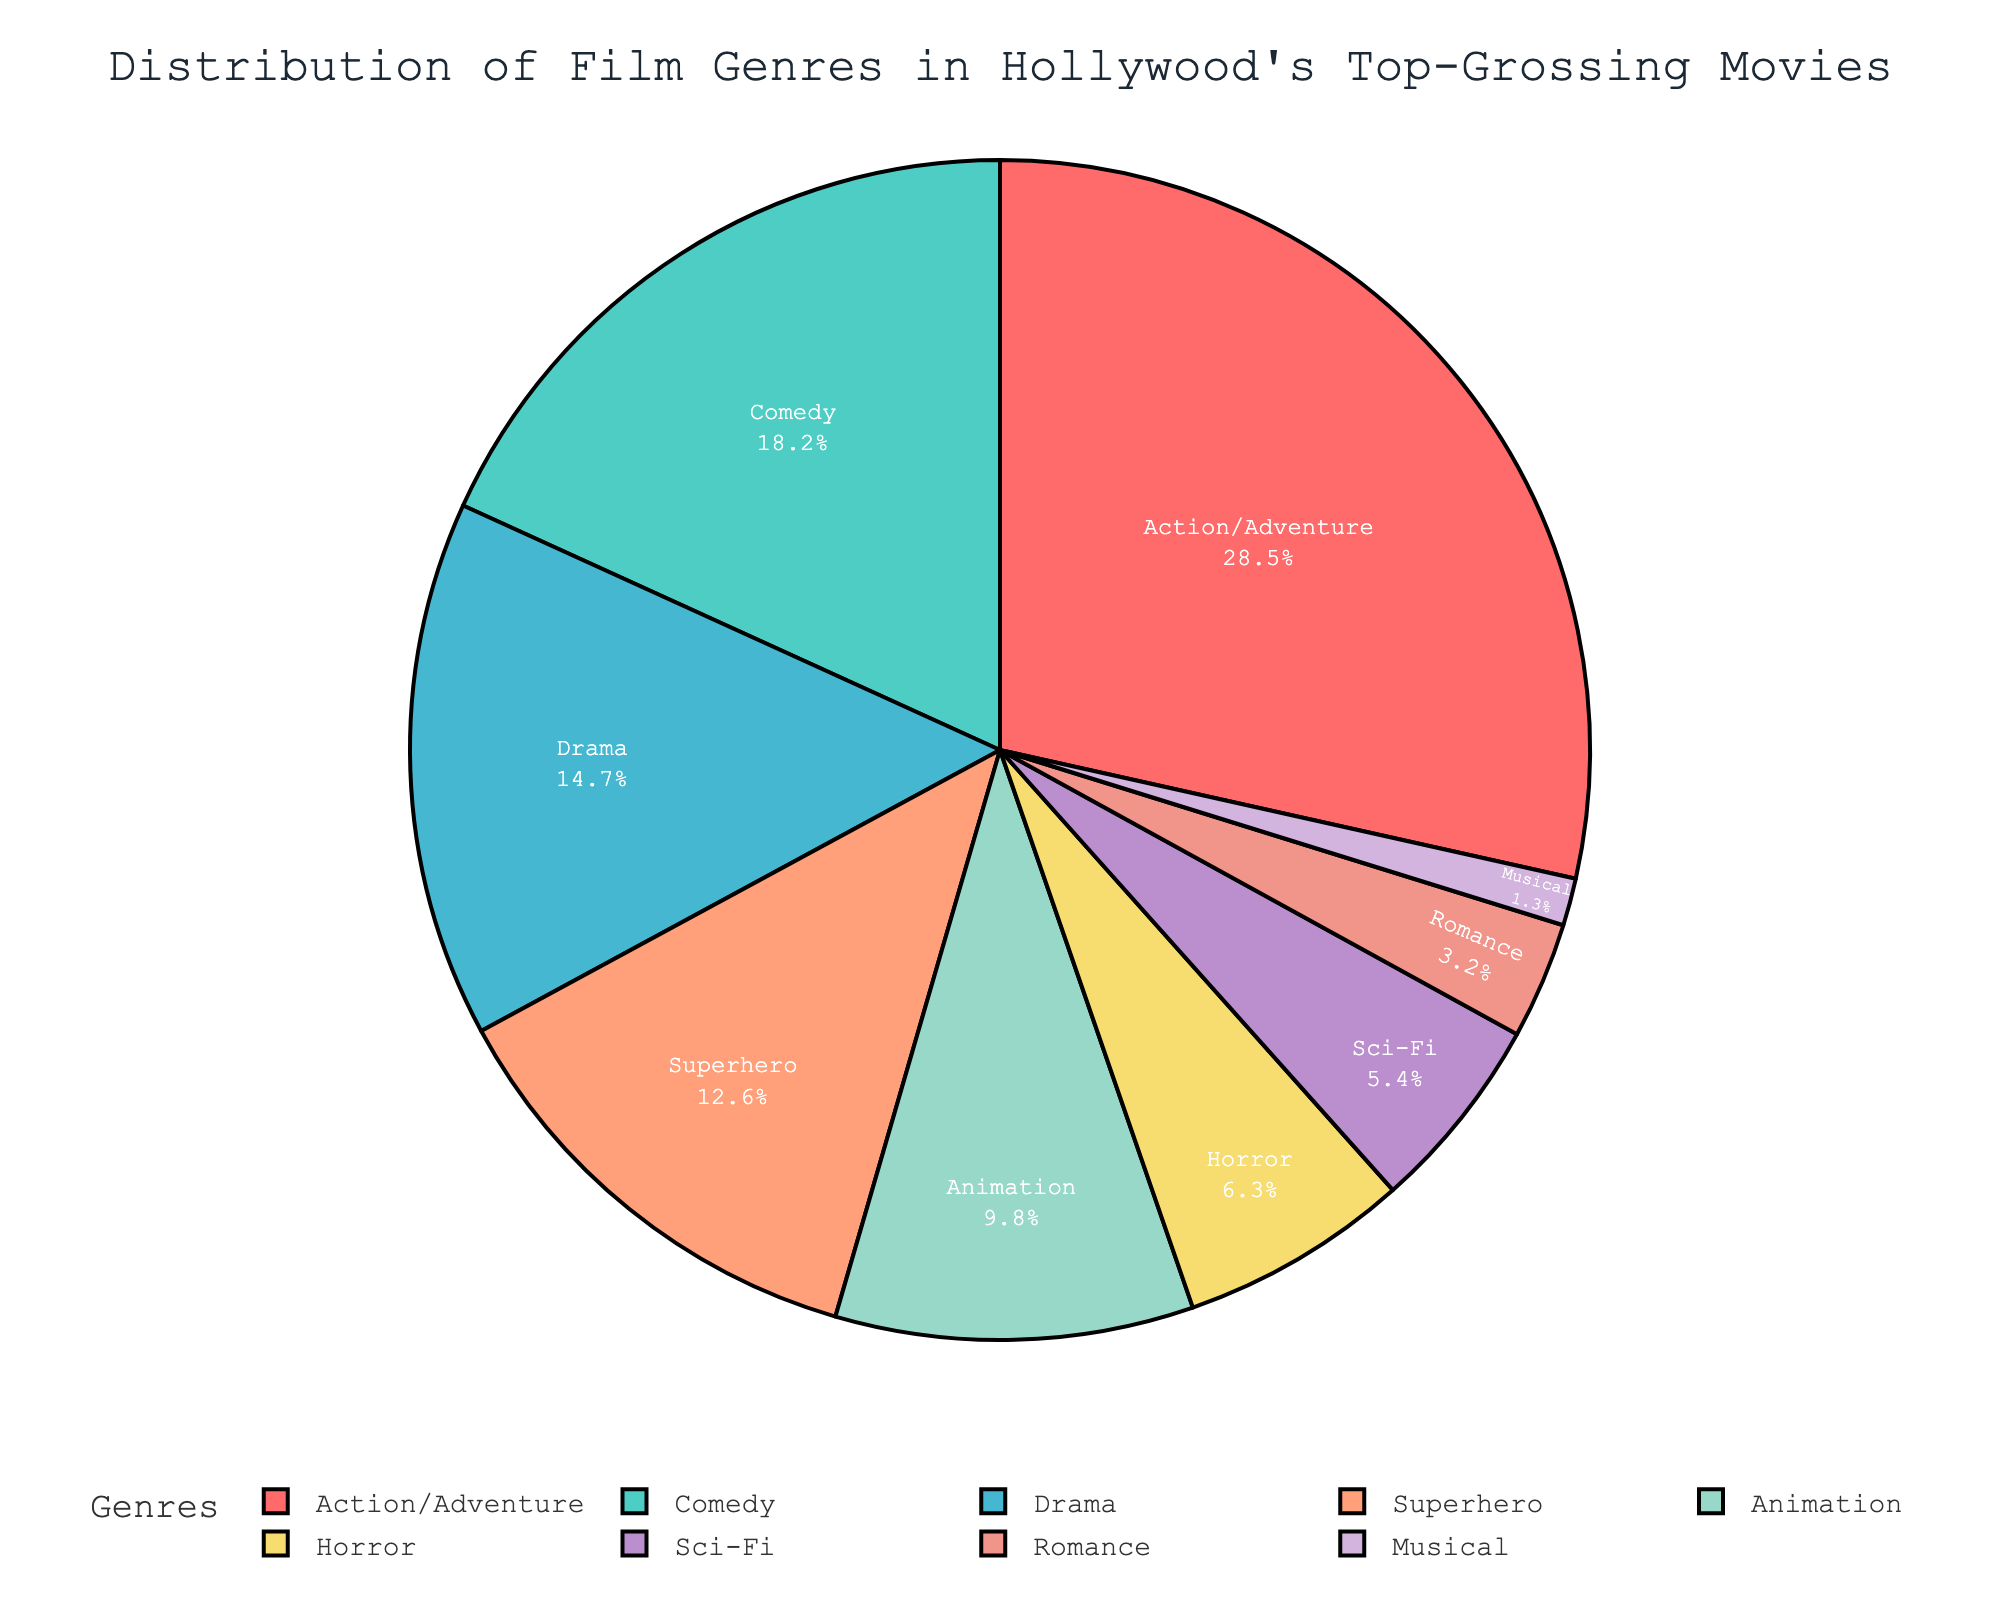What is the most represented genre in Hollywood's top-grossing movies? The pie chart shows the largest segment representing genres. The Action/Adventure genre has the largest segment, indicating it is the most represented.
Answer: Action/Adventure Which genre has the smallest percentage share? By looking at the smallest segment in the pie chart, the genre with the least representation can be identified. The Musical genre has the smallest segment.
Answer: Musical What is the combined percentage of Comedy and Drama genres? Adding the percentage values for Comedy and Drama genres: 18.2% + 14.7% = 32.9%.
Answer: 32.9% How much more percentage does the Action/Adventure genre have compared to the Horror genre? Subtract the percentage of the Horror genre from the Action/Adventure genre: 28.5% - 6.3% = 22.2%.
Answer: 22.2% Rank the top three genres in terms of their percentage share. From the pie chart, the three largest segments represent the top three genres. They are Action/Adventure (28.5%), Comedy (18.2%), and Drama (14.7%).
Answer: Action/Adventure, Comedy, Drama What is the percentage difference between the Animation and Sci-Fi genres? Subtract the percentage of the Sci-Fi genre from the Animation genre: 9.8% - 5.4% = 4.4%.
Answer: 4.4% Which genre occupies the largest segment after Action/Adventure and Comedy are excluded? After identifying and excluding the Action/Adventure and Comedy segments, Drama is the next largest segment.
Answer: Drama Do the top three genres combined occupy more than half the pie chart? Sum the percentages for Action/Adventure, Comedy, and Drama: 28.5% + 18.2% + 14.7% = 61.4%. Since 61.4% is more than 50%, they occupy more than half.
Answer: Yes How does the share of Superhero genre compare to the share of the Horror genre? The pie chart shows the percentage of the Superhero genre (12.6%) and the Horror genre (6.3%). The Superhero share is larger.
Answer: Superhero is larger What percentage of the top-grossing movies are not Action/Adventure, Comedy, or Drama? Subtract the sum of Action/Adventure, Comedy, and Drama percentages from 100%: 100% - (28.5% + 18.2% + 14.7%) = 38.6%.
Answer: 38.6% 